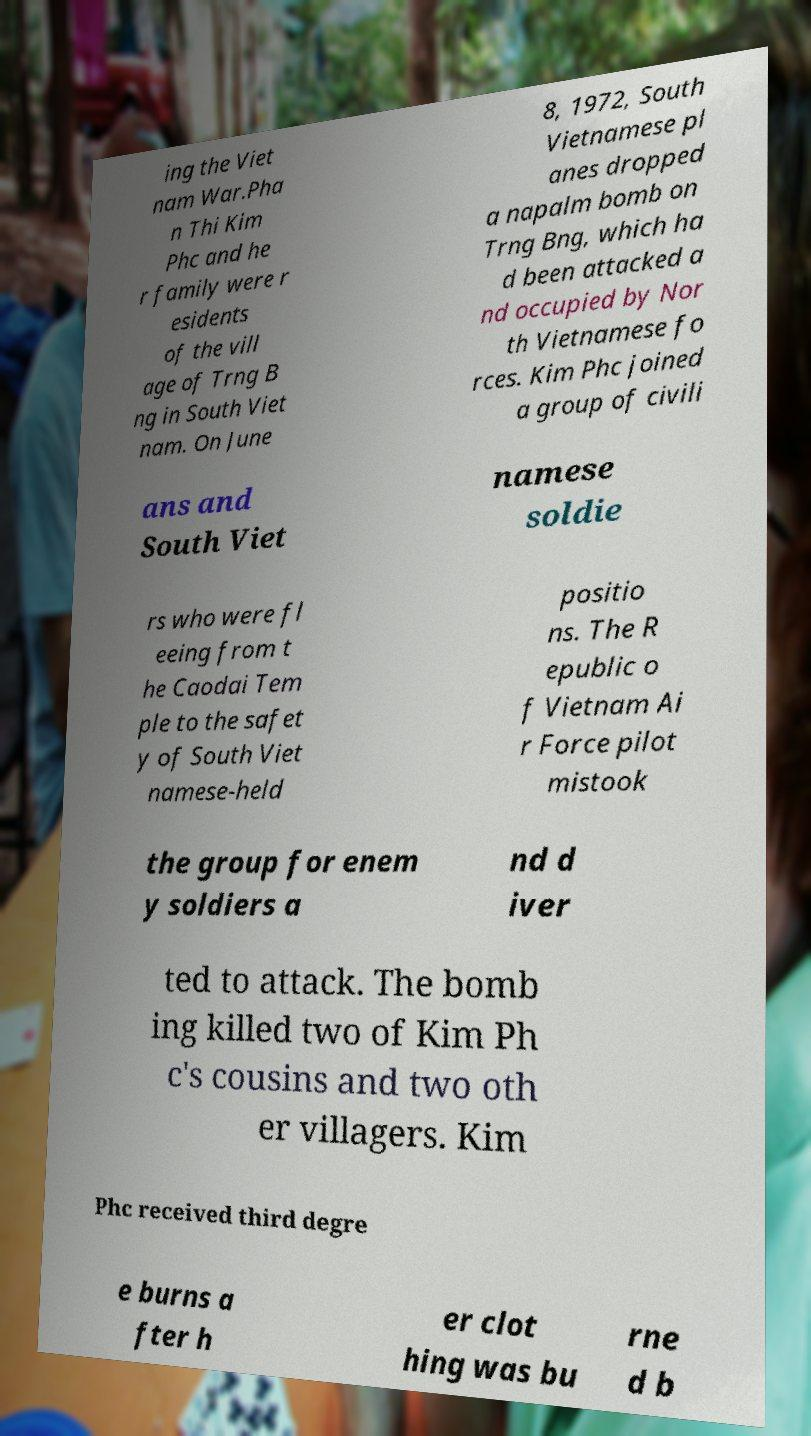Can you read and provide the text displayed in the image?This photo seems to have some interesting text. Can you extract and type it out for me? ing the Viet nam War.Pha n Thi Kim Phc and he r family were r esidents of the vill age of Trng B ng in South Viet nam. On June 8, 1972, South Vietnamese pl anes dropped a napalm bomb on Trng Bng, which ha d been attacked a nd occupied by Nor th Vietnamese fo rces. Kim Phc joined a group of civili ans and South Viet namese soldie rs who were fl eeing from t he Caodai Tem ple to the safet y of South Viet namese-held positio ns. The R epublic o f Vietnam Ai r Force pilot mistook the group for enem y soldiers a nd d iver ted to attack. The bomb ing killed two of Kim Ph c's cousins and two oth er villagers. Kim Phc received third degre e burns a fter h er clot hing was bu rne d b 